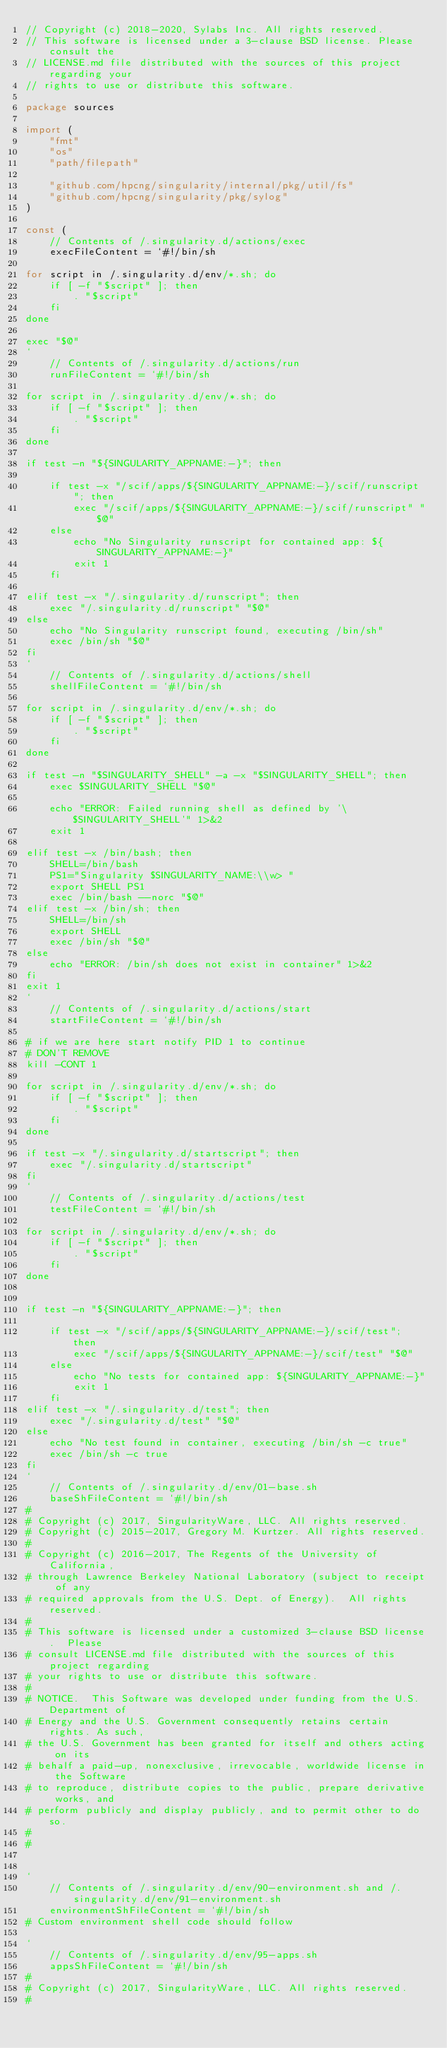<code> <loc_0><loc_0><loc_500><loc_500><_Go_>// Copyright (c) 2018-2020, Sylabs Inc. All rights reserved.
// This software is licensed under a 3-clause BSD license. Please consult the
// LICENSE.md file distributed with the sources of this project regarding your
// rights to use or distribute this software.

package sources

import (
	"fmt"
	"os"
	"path/filepath"

	"github.com/hpcng/singularity/internal/pkg/util/fs"
	"github.com/hpcng/singularity/pkg/sylog"
)

const (
	// Contents of /.singularity.d/actions/exec
	execFileContent = `#!/bin/sh

for script in /.singularity.d/env/*.sh; do
    if [ -f "$script" ]; then
        . "$script"
    fi
done

exec "$@"
`
	// Contents of /.singularity.d/actions/run
	runFileContent = `#!/bin/sh

for script in /.singularity.d/env/*.sh; do
    if [ -f "$script" ]; then
        . "$script"
    fi
done

if test -n "${SINGULARITY_APPNAME:-}"; then

    if test -x "/scif/apps/${SINGULARITY_APPNAME:-}/scif/runscript"; then
        exec "/scif/apps/${SINGULARITY_APPNAME:-}/scif/runscript" "$@"
    else
        echo "No Singularity runscript for contained app: ${SINGULARITY_APPNAME:-}"
        exit 1
    fi

elif test -x "/.singularity.d/runscript"; then
    exec "/.singularity.d/runscript" "$@"
else
    echo "No Singularity runscript found, executing /bin/sh"
    exec /bin/sh "$@"
fi
`
	// Contents of /.singularity.d/actions/shell
	shellFileContent = `#!/bin/sh

for script in /.singularity.d/env/*.sh; do
    if [ -f "$script" ]; then
        . "$script"
    fi
done

if test -n "$SINGULARITY_SHELL" -a -x "$SINGULARITY_SHELL"; then
    exec $SINGULARITY_SHELL "$@"

    echo "ERROR: Failed running shell as defined by '\$SINGULARITY_SHELL'" 1>&2
    exit 1

elif test -x /bin/bash; then
    SHELL=/bin/bash
    PS1="Singularity $SINGULARITY_NAME:\\w> "
    export SHELL PS1
    exec /bin/bash --norc "$@"
elif test -x /bin/sh; then
    SHELL=/bin/sh
    export SHELL
    exec /bin/sh "$@"
else
    echo "ERROR: /bin/sh does not exist in container" 1>&2
fi
exit 1
`
	// Contents of /.singularity.d/actions/start
	startFileContent = `#!/bin/sh

# if we are here start notify PID 1 to continue
# DON'T REMOVE
kill -CONT 1

for script in /.singularity.d/env/*.sh; do
    if [ -f "$script" ]; then
        . "$script"
    fi
done

if test -x "/.singularity.d/startscript"; then
    exec "/.singularity.d/startscript"
fi
`
	// Contents of /.singularity.d/actions/test
	testFileContent = `#!/bin/sh

for script in /.singularity.d/env/*.sh; do
    if [ -f "$script" ]; then
        . "$script"
    fi
done


if test -n "${SINGULARITY_APPNAME:-}"; then

    if test -x "/scif/apps/${SINGULARITY_APPNAME:-}/scif/test"; then
        exec "/scif/apps/${SINGULARITY_APPNAME:-}/scif/test" "$@"
    else
        echo "No tests for contained app: ${SINGULARITY_APPNAME:-}"
        exit 1
    fi
elif test -x "/.singularity.d/test"; then
    exec "/.singularity.d/test" "$@"
else
    echo "No test found in container, executing /bin/sh -c true"
    exec /bin/sh -c true
fi
`
	// Contents of /.singularity.d/env/01-base.sh
	baseShFileContent = `#!/bin/sh
# 
# Copyright (c) 2017, SingularityWare, LLC. All rights reserved.
# Copyright (c) 2015-2017, Gregory M. Kurtzer. All rights reserved.
# 
# Copyright (c) 2016-2017, The Regents of the University of California,
# through Lawrence Berkeley National Laboratory (subject to receipt of any
# required approvals from the U.S. Dept. of Energy).  All rights reserved.
# 
# This software is licensed under a customized 3-clause BSD license.  Please
# consult LICENSE.md file distributed with the sources of this project regarding
# your rights to use or distribute this software.
# 
# NOTICE.  This Software was developed under funding from the U.S. Department of
# Energy and the U.S. Government consequently retains certain rights. As such,
# the U.S. Government has been granted for itself and others acting on its
# behalf a paid-up, nonexclusive, irrevocable, worldwide license in the Software
# to reproduce, distribute copies to the public, prepare derivative works, and
# perform publicly and display publicly, and to permit other to do so.
# 
# 


`
	// Contents of /.singularity.d/env/90-environment.sh and /.singularity.d/env/91-environment.sh
	environmentShFileContent = `#!/bin/sh
# Custom environment shell code should follow

`
	// Contents of /.singularity.d/env/95-apps.sh
	appsShFileContent = `#!/bin/sh
#
# Copyright (c) 2017, SingularityWare, LLC. All rights reserved.
#</code> 